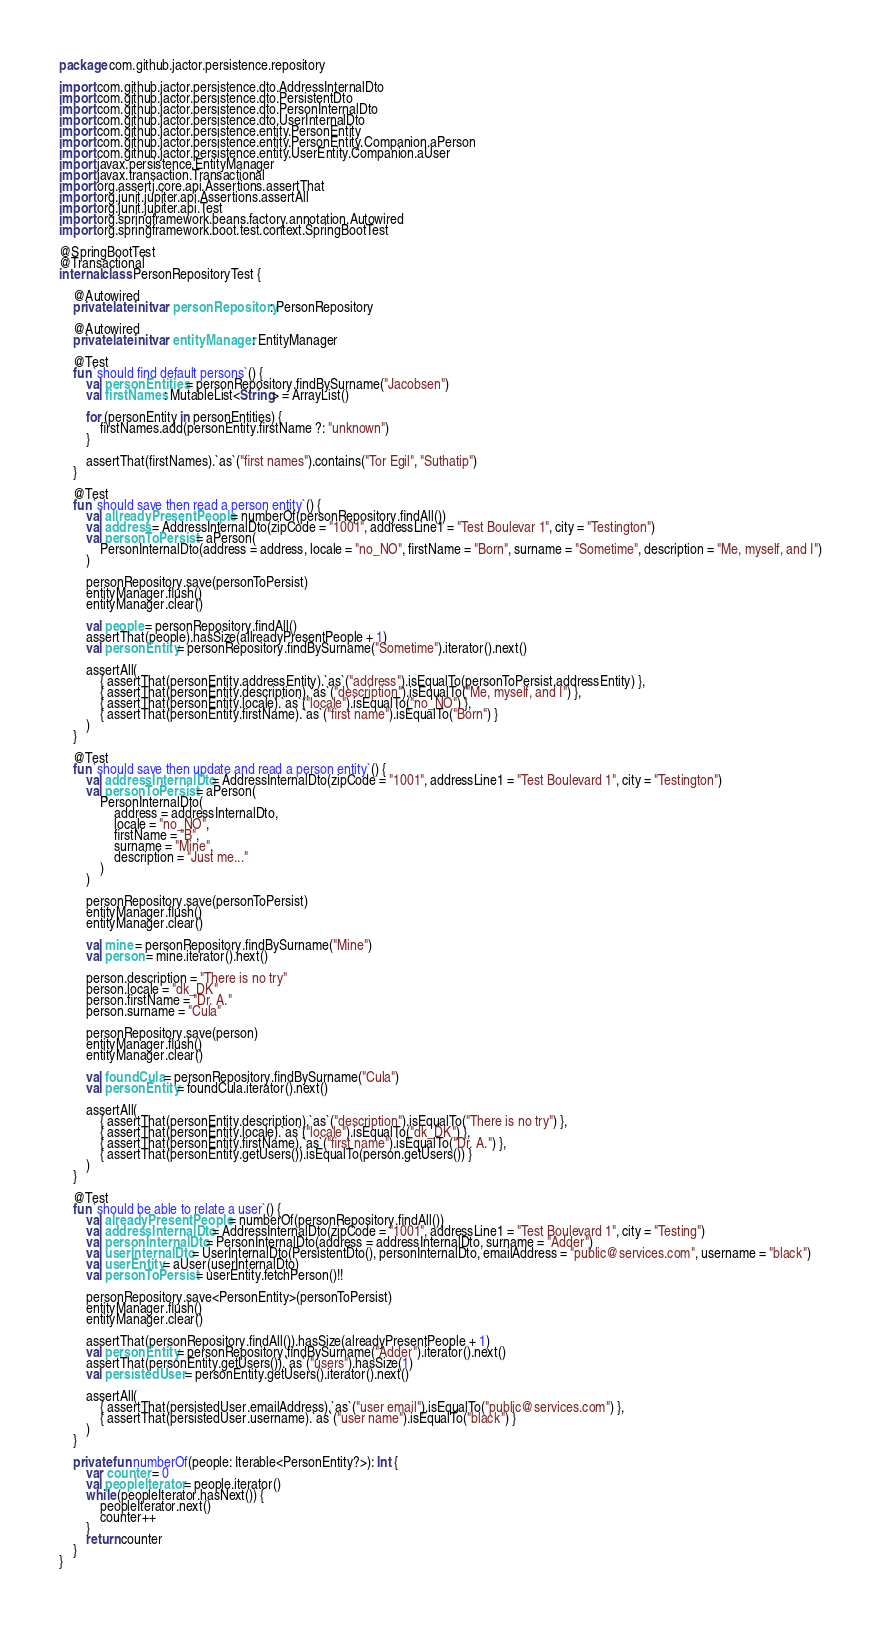<code> <loc_0><loc_0><loc_500><loc_500><_Kotlin_>package com.github.jactor.persistence.repository

import com.github.jactor.persistence.dto.AddressInternalDto
import com.github.jactor.persistence.dto.PersistentDto
import com.github.jactor.persistence.dto.PersonInternalDto
import com.github.jactor.persistence.dto.UserInternalDto
import com.github.jactor.persistence.entity.PersonEntity
import com.github.jactor.persistence.entity.PersonEntity.Companion.aPerson
import com.github.jactor.persistence.entity.UserEntity.Companion.aUser
import javax.persistence.EntityManager
import javax.transaction.Transactional
import org.assertj.core.api.Assertions.assertThat
import org.junit.jupiter.api.Assertions.assertAll
import org.junit.jupiter.api.Test
import org.springframework.beans.factory.annotation.Autowired
import org.springframework.boot.test.context.SpringBootTest

@SpringBootTest
@Transactional
internal class PersonRepositoryTest {

    @Autowired
    private lateinit var personRepository: PersonRepository

    @Autowired
    private lateinit var entityManager: EntityManager

    @Test
    fun `should find default persons`() {
        val personEntities = personRepository.findBySurname("Jacobsen")
        val firstNames: MutableList<String> = ArrayList()

        for (personEntity in personEntities) {
            firstNames.add(personEntity.firstName ?: "unknown")
        }

        assertThat(firstNames).`as`("first names").contains("Tor Egil", "Suthatip")
    }

    @Test
    fun `should save then read a person entity`() {
        val allreadyPresentPeople = numberOf(personRepository.findAll())
        val address = AddressInternalDto(zipCode = "1001", addressLine1 = "Test Boulevar 1", city = "Testington")
        val personToPersist = aPerson(
            PersonInternalDto(address = address, locale = "no_NO", firstName = "Born", surname = "Sometime", description = "Me, myself, and I")
        )

        personRepository.save(personToPersist)
        entityManager.flush()
        entityManager.clear()

        val people = personRepository.findAll()
        assertThat(people).hasSize(allreadyPresentPeople + 1)
        val personEntity = personRepository.findBySurname("Sometime").iterator().next()

        assertAll(
            { assertThat(personEntity.addressEntity).`as`("address").isEqualTo(personToPersist.addressEntity) },
            { assertThat(personEntity.description).`as`("description").isEqualTo("Me, myself, and I") },
            { assertThat(personEntity.locale).`as`("locale").isEqualTo("no_NO") },
            { assertThat(personEntity.firstName).`as`("first name").isEqualTo("Born") }
        )
    }

    @Test
    fun `should save then update and read a person entity`() {
        val addressInternalDto = AddressInternalDto(zipCode = "1001", addressLine1 = "Test Boulevard 1", city = "Testington")
        val personToPersist = aPerson(
            PersonInternalDto(
                address = addressInternalDto,
                locale = "no_NO",
                firstName = "B",
                surname = "Mine",
                description = "Just me..."
            )
        )

        personRepository.save(personToPersist)
        entityManager.flush()
        entityManager.clear()

        val mine = personRepository.findBySurname("Mine")
        val person = mine.iterator().next()

        person.description = "There is no try"
        person.locale = "dk_DK"
        person.firstName = "Dr. A."
        person.surname = "Cula"

        personRepository.save(person)
        entityManager.flush()
        entityManager.clear()

        val foundCula = personRepository.findBySurname("Cula")
        val personEntity = foundCula.iterator().next()

        assertAll(
            { assertThat(personEntity.description).`as`("description").isEqualTo("There is no try") },
            { assertThat(personEntity.locale).`as`("locale").isEqualTo("dk_DK") },
            { assertThat(personEntity.firstName).`as`("first name").isEqualTo("Dr. A.") },
            { assertThat(personEntity.getUsers()).isEqualTo(person.getUsers()) }
        )
    }

    @Test
    fun `should be able to relate a user`() {
        val alreadyPresentPeople = numberOf(personRepository.findAll())
        val addressInternalDto = AddressInternalDto(zipCode = "1001", addressLine1 = "Test Boulevard 1", city = "Testing")
        val personInternalDto = PersonInternalDto(address = addressInternalDto, surname = "Adder")
        val userInternalDto = UserInternalDto(PersistentDto(), personInternalDto, emailAddress = "public@services.com", username = "black")
        val userEntity = aUser(userInternalDto)
        val personToPersist = userEntity.fetchPerson()!!

        personRepository.save<PersonEntity>(personToPersist)
        entityManager.flush()
        entityManager.clear()

        assertThat(personRepository.findAll()).hasSize(alreadyPresentPeople + 1)
        val personEntity = personRepository.findBySurname("Adder").iterator().next()
        assertThat(personEntity.getUsers()).`as`("users").hasSize(1)
        val persistedUser = personEntity.getUsers().iterator().next()

        assertAll(
            { assertThat(persistedUser.emailAddress).`as`("user email").isEqualTo("public@services.com") },
            { assertThat(persistedUser.username).`as`("user name").isEqualTo("black") }
        )
    }

    private fun numberOf(people: Iterable<PersonEntity?>): Int {
        var counter = 0
        val peopleIterator = people.iterator()
        while (peopleIterator.hasNext()) {
            peopleIterator.next()
            counter++
        }
        return counter
    }
}</code> 